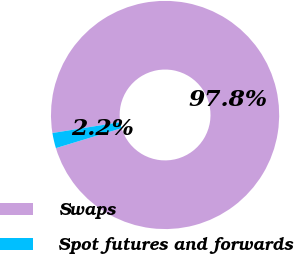<chart> <loc_0><loc_0><loc_500><loc_500><pie_chart><fcel>Swaps<fcel>Spot futures and forwards<nl><fcel>97.84%<fcel>2.16%<nl></chart> 